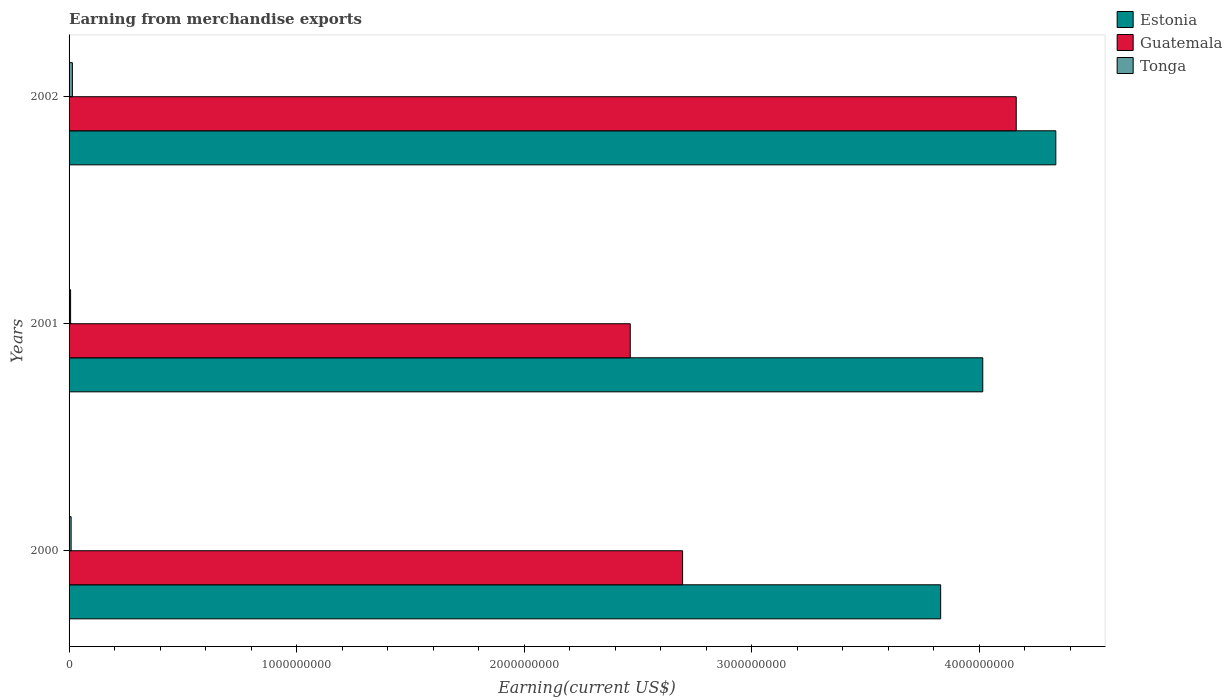How many different coloured bars are there?
Keep it short and to the point. 3. How many bars are there on the 3rd tick from the top?
Your response must be concise. 3. How many bars are there on the 3rd tick from the bottom?
Provide a succinct answer. 3. What is the label of the 2nd group of bars from the top?
Provide a succinct answer. 2001. In how many cases, is the number of bars for a given year not equal to the number of legend labels?
Provide a succinct answer. 0. What is the amount earned from merchandise exports in Estonia in 2001?
Your answer should be very brief. 4.02e+09. Across all years, what is the maximum amount earned from merchandise exports in Tonga?
Your answer should be very brief. 1.45e+07. Across all years, what is the minimum amount earned from merchandise exports in Tonga?
Your answer should be very brief. 6.72e+06. In which year was the amount earned from merchandise exports in Tonga maximum?
Your answer should be very brief. 2002. In which year was the amount earned from merchandise exports in Estonia minimum?
Ensure brevity in your answer.  2000. What is the total amount earned from merchandise exports in Tonga in the graph?
Your response must be concise. 3.03e+07. What is the difference between the amount earned from merchandise exports in Tonga in 2001 and that in 2002?
Your answer should be very brief. -7.82e+06. What is the difference between the amount earned from merchandise exports in Tonga in 2000 and the amount earned from merchandise exports in Guatemala in 2002?
Offer a terse response. -4.15e+09. What is the average amount earned from merchandise exports in Estonia per year?
Offer a terse response. 4.06e+09. In the year 2001, what is the difference between the amount earned from merchandise exports in Guatemala and amount earned from merchandise exports in Estonia?
Your response must be concise. -1.55e+09. What is the ratio of the amount earned from merchandise exports in Guatemala in 2000 to that in 2002?
Make the answer very short. 0.65. What is the difference between the highest and the second highest amount earned from merchandise exports in Estonia?
Make the answer very short. 3.21e+08. What is the difference between the highest and the lowest amount earned from merchandise exports in Guatemala?
Offer a terse response. 1.70e+09. Is the sum of the amount earned from merchandise exports in Estonia in 2001 and 2002 greater than the maximum amount earned from merchandise exports in Guatemala across all years?
Your answer should be very brief. Yes. What does the 3rd bar from the top in 2000 represents?
Your answer should be compact. Estonia. What does the 1st bar from the bottom in 2000 represents?
Your response must be concise. Estonia. Is it the case that in every year, the sum of the amount earned from merchandise exports in Tonga and amount earned from merchandise exports in Estonia is greater than the amount earned from merchandise exports in Guatemala?
Ensure brevity in your answer.  Yes. Are all the bars in the graph horizontal?
Offer a very short reply. Yes. How many years are there in the graph?
Your response must be concise. 3. Are the values on the major ticks of X-axis written in scientific E-notation?
Your response must be concise. No. Does the graph contain grids?
Your answer should be compact. No. Where does the legend appear in the graph?
Give a very brief answer. Top right. How are the legend labels stacked?
Provide a short and direct response. Vertical. What is the title of the graph?
Keep it short and to the point. Earning from merchandise exports. Does "Nepal" appear as one of the legend labels in the graph?
Keep it short and to the point. No. What is the label or title of the X-axis?
Your answer should be compact. Earning(current US$). What is the label or title of the Y-axis?
Provide a short and direct response. Years. What is the Earning(current US$) of Estonia in 2000?
Give a very brief answer. 3.83e+09. What is the Earning(current US$) of Guatemala in 2000?
Your response must be concise. 2.70e+09. What is the Earning(current US$) in Tonga in 2000?
Ensure brevity in your answer.  9.00e+06. What is the Earning(current US$) of Estonia in 2001?
Make the answer very short. 4.02e+09. What is the Earning(current US$) of Guatemala in 2001?
Keep it short and to the point. 2.47e+09. What is the Earning(current US$) of Tonga in 2001?
Make the answer very short. 6.72e+06. What is the Earning(current US$) in Estonia in 2002?
Provide a succinct answer. 4.34e+09. What is the Earning(current US$) in Guatemala in 2002?
Your answer should be very brief. 4.16e+09. What is the Earning(current US$) in Tonga in 2002?
Keep it short and to the point. 1.45e+07. Across all years, what is the maximum Earning(current US$) in Estonia?
Keep it short and to the point. 4.34e+09. Across all years, what is the maximum Earning(current US$) in Guatemala?
Your answer should be very brief. 4.16e+09. Across all years, what is the maximum Earning(current US$) in Tonga?
Give a very brief answer. 1.45e+07. Across all years, what is the minimum Earning(current US$) in Estonia?
Provide a succinct answer. 3.83e+09. Across all years, what is the minimum Earning(current US$) in Guatemala?
Give a very brief answer. 2.47e+09. Across all years, what is the minimum Earning(current US$) of Tonga?
Give a very brief answer. 6.72e+06. What is the total Earning(current US$) of Estonia in the graph?
Your answer should be very brief. 1.22e+1. What is the total Earning(current US$) in Guatemala in the graph?
Keep it short and to the point. 9.32e+09. What is the total Earning(current US$) of Tonga in the graph?
Make the answer very short. 3.03e+07. What is the difference between the Earning(current US$) in Estonia in 2000 and that in 2001?
Your answer should be very brief. -1.85e+08. What is the difference between the Earning(current US$) in Guatemala in 2000 and that in 2001?
Provide a succinct answer. 2.30e+08. What is the difference between the Earning(current US$) of Tonga in 2000 and that in 2001?
Keep it short and to the point. 2.28e+06. What is the difference between the Earning(current US$) in Estonia in 2000 and that in 2002?
Offer a terse response. -5.06e+08. What is the difference between the Earning(current US$) in Guatemala in 2000 and that in 2002?
Your answer should be compact. -1.47e+09. What is the difference between the Earning(current US$) of Tonga in 2000 and that in 2002?
Keep it short and to the point. -5.54e+06. What is the difference between the Earning(current US$) in Estonia in 2001 and that in 2002?
Keep it short and to the point. -3.21e+08. What is the difference between the Earning(current US$) of Guatemala in 2001 and that in 2002?
Ensure brevity in your answer.  -1.70e+09. What is the difference between the Earning(current US$) of Tonga in 2001 and that in 2002?
Your answer should be very brief. -7.82e+06. What is the difference between the Earning(current US$) in Estonia in 2000 and the Earning(current US$) in Guatemala in 2001?
Ensure brevity in your answer.  1.36e+09. What is the difference between the Earning(current US$) in Estonia in 2000 and the Earning(current US$) in Tonga in 2001?
Provide a short and direct response. 3.82e+09. What is the difference between the Earning(current US$) in Guatemala in 2000 and the Earning(current US$) in Tonga in 2001?
Provide a short and direct response. 2.69e+09. What is the difference between the Earning(current US$) of Estonia in 2000 and the Earning(current US$) of Guatemala in 2002?
Make the answer very short. -3.32e+08. What is the difference between the Earning(current US$) of Estonia in 2000 and the Earning(current US$) of Tonga in 2002?
Ensure brevity in your answer.  3.82e+09. What is the difference between the Earning(current US$) in Guatemala in 2000 and the Earning(current US$) in Tonga in 2002?
Keep it short and to the point. 2.68e+09. What is the difference between the Earning(current US$) of Estonia in 2001 and the Earning(current US$) of Guatemala in 2002?
Provide a short and direct response. -1.47e+08. What is the difference between the Earning(current US$) in Estonia in 2001 and the Earning(current US$) in Tonga in 2002?
Ensure brevity in your answer.  4.00e+09. What is the difference between the Earning(current US$) of Guatemala in 2001 and the Earning(current US$) of Tonga in 2002?
Offer a very short reply. 2.45e+09. What is the average Earning(current US$) in Estonia per year?
Give a very brief answer. 4.06e+09. What is the average Earning(current US$) of Guatemala per year?
Offer a very short reply. 3.11e+09. What is the average Earning(current US$) of Tonga per year?
Provide a short and direct response. 1.01e+07. In the year 2000, what is the difference between the Earning(current US$) in Estonia and Earning(current US$) in Guatemala?
Ensure brevity in your answer.  1.13e+09. In the year 2000, what is the difference between the Earning(current US$) of Estonia and Earning(current US$) of Tonga?
Your response must be concise. 3.82e+09. In the year 2000, what is the difference between the Earning(current US$) in Guatemala and Earning(current US$) in Tonga?
Ensure brevity in your answer.  2.69e+09. In the year 2001, what is the difference between the Earning(current US$) of Estonia and Earning(current US$) of Guatemala?
Ensure brevity in your answer.  1.55e+09. In the year 2001, what is the difference between the Earning(current US$) of Estonia and Earning(current US$) of Tonga?
Your answer should be very brief. 4.01e+09. In the year 2001, what is the difference between the Earning(current US$) of Guatemala and Earning(current US$) of Tonga?
Offer a very short reply. 2.46e+09. In the year 2002, what is the difference between the Earning(current US$) in Estonia and Earning(current US$) in Guatemala?
Your answer should be very brief. 1.74e+08. In the year 2002, what is the difference between the Earning(current US$) in Estonia and Earning(current US$) in Tonga?
Your response must be concise. 4.32e+09. In the year 2002, what is the difference between the Earning(current US$) in Guatemala and Earning(current US$) in Tonga?
Offer a terse response. 4.15e+09. What is the ratio of the Earning(current US$) of Estonia in 2000 to that in 2001?
Your answer should be compact. 0.95. What is the ratio of the Earning(current US$) of Guatemala in 2000 to that in 2001?
Your answer should be very brief. 1.09. What is the ratio of the Earning(current US$) in Tonga in 2000 to that in 2001?
Provide a short and direct response. 1.34. What is the ratio of the Earning(current US$) of Estonia in 2000 to that in 2002?
Give a very brief answer. 0.88. What is the ratio of the Earning(current US$) of Guatemala in 2000 to that in 2002?
Your answer should be very brief. 0.65. What is the ratio of the Earning(current US$) of Tonga in 2000 to that in 2002?
Give a very brief answer. 0.62. What is the ratio of the Earning(current US$) in Estonia in 2001 to that in 2002?
Ensure brevity in your answer.  0.93. What is the ratio of the Earning(current US$) of Guatemala in 2001 to that in 2002?
Offer a very short reply. 0.59. What is the ratio of the Earning(current US$) in Tonga in 2001 to that in 2002?
Provide a succinct answer. 0.46. What is the difference between the highest and the second highest Earning(current US$) in Estonia?
Offer a terse response. 3.21e+08. What is the difference between the highest and the second highest Earning(current US$) in Guatemala?
Provide a succinct answer. 1.47e+09. What is the difference between the highest and the second highest Earning(current US$) in Tonga?
Provide a short and direct response. 5.54e+06. What is the difference between the highest and the lowest Earning(current US$) of Estonia?
Make the answer very short. 5.06e+08. What is the difference between the highest and the lowest Earning(current US$) of Guatemala?
Your response must be concise. 1.70e+09. What is the difference between the highest and the lowest Earning(current US$) in Tonga?
Offer a terse response. 7.82e+06. 